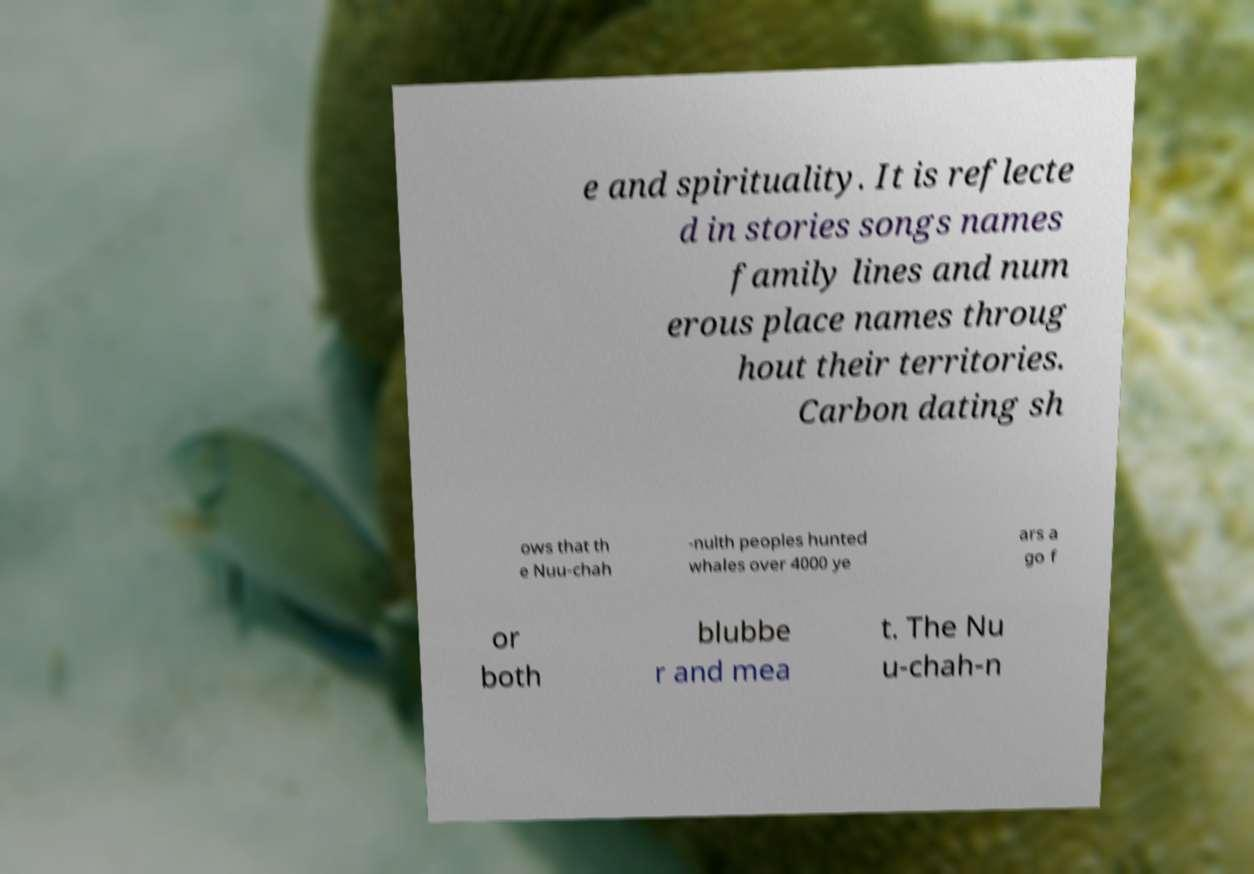Please identify and transcribe the text found in this image. e and spirituality. It is reflecte d in stories songs names family lines and num erous place names throug hout their territories. Carbon dating sh ows that th e Nuu-chah -nulth peoples hunted whales over 4000 ye ars a go f or both blubbe r and mea t. The Nu u-chah-n 